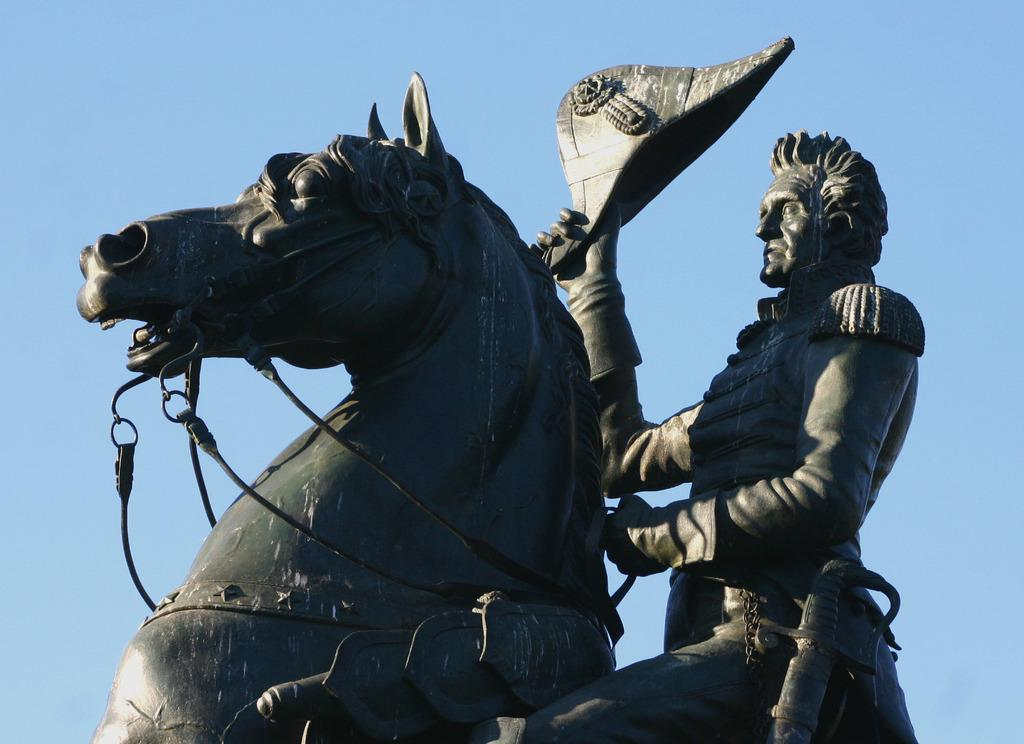What is the main subject of the image? There is a statue of a horse in the image. Are there any other subjects or objects in the image? Yes, there is a person in the image. What is the person holding? The person is holding a hat. What type of key is the person using to unlock the sun in the image? There is no key or sun present in the image; it only features a statue of a horse and a person holding a hat. 